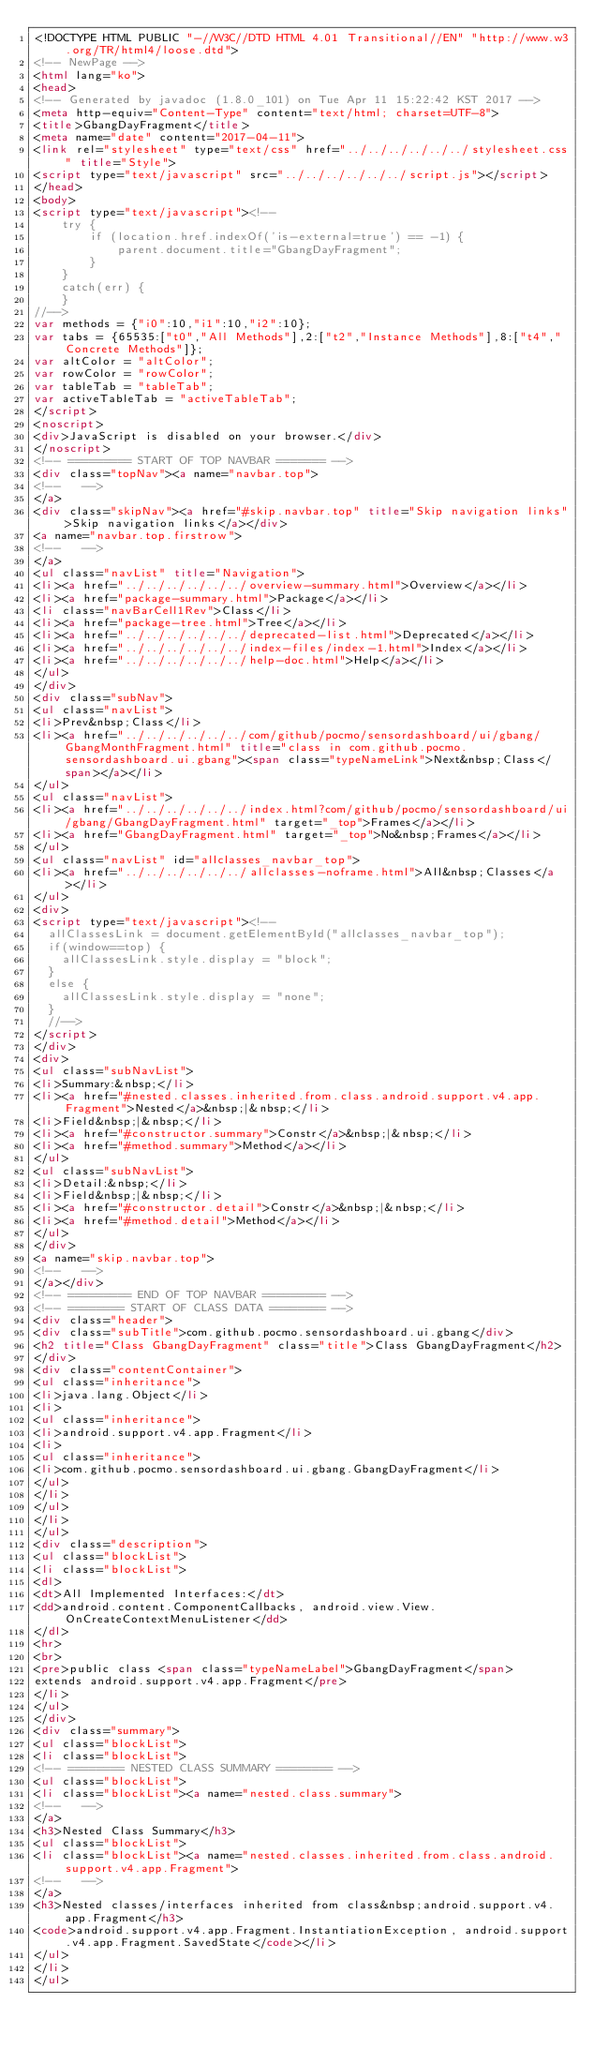<code> <loc_0><loc_0><loc_500><loc_500><_HTML_><!DOCTYPE HTML PUBLIC "-//W3C//DTD HTML 4.01 Transitional//EN" "http://www.w3.org/TR/html4/loose.dtd">
<!-- NewPage -->
<html lang="ko">
<head>
<!-- Generated by javadoc (1.8.0_101) on Tue Apr 11 15:22:42 KST 2017 -->
<meta http-equiv="Content-Type" content="text/html; charset=UTF-8">
<title>GbangDayFragment</title>
<meta name="date" content="2017-04-11">
<link rel="stylesheet" type="text/css" href="../../../../../../stylesheet.css" title="Style">
<script type="text/javascript" src="../../../../../../script.js"></script>
</head>
<body>
<script type="text/javascript"><!--
    try {
        if (location.href.indexOf('is-external=true') == -1) {
            parent.document.title="GbangDayFragment";
        }
    }
    catch(err) {
    }
//-->
var methods = {"i0":10,"i1":10,"i2":10};
var tabs = {65535:["t0","All Methods"],2:["t2","Instance Methods"],8:["t4","Concrete Methods"]};
var altColor = "altColor";
var rowColor = "rowColor";
var tableTab = "tableTab";
var activeTableTab = "activeTableTab";
</script>
<noscript>
<div>JavaScript is disabled on your browser.</div>
</noscript>
<!-- ========= START OF TOP NAVBAR ======= -->
<div class="topNav"><a name="navbar.top">
<!--   -->
</a>
<div class="skipNav"><a href="#skip.navbar.top" title="Skip navigation links">Skip navigation links</a></div>
<a name="navbar.top.firstrow">
<!--   -->
</a>
<ul class="navList" title="Navigation">
<li><a href="../../../../../../overview-summary.html">Overview</a></li>
<li><a href="package-summary.html">Package</a></li>
<li class="navBarCell1Rev">Class</li>
<li><a href="package-tree.html">Tree</a></li>
<li><a href="../../../../../../deprecated-list.html">Deprecated</a></li>
<li><a href="../../../../../../index-files/index-1.html">Index</a></li>
<li><a href="../../../../../../help-doc.html">Help</a></li>
</ul>
</div>
<div class="subNav">
<ul class="navList">
<li>Prev&nbsp;Class</li>
<li><a href="../../../../../../com/github/pocmo/sensordashboard/ui/gbang/GbangMonthFragment.html" title="class in com.github.pocmo.sensordashboard.ui.gbang"><span class="typeNameLink">Next&nbsp;Class</span></a></li>
</ul>
<ul class="navList">
<li><a href="../../../../../../index.html?com/github/pocmo/sensordashboard/ui/gbang/GbangDayFragment.html" target="_top">Frames</a></li>
<li><a href="GbangDayFragment.html" target="_top">No&nbsp;Frames</a></li>
</ul>
<ul class="navList" id="allclasses_navbar_top">
<li><a href="../../../../../../allclasses-noframe.html">All&nbsp;Classes</a></li>
</ul>
<div>
<script type="text/javascript"><!--
  allClassesLink = document.getElementById("allclasses_navbar_top");
  if(window==top) {
    allClassesLink.style.display = "block";
  }
  else {
    allClassesLink.style.display = "none";
  }
  //-->
</script>
</div>
<div>
<ul class="subNavList">
<li>Summary:&nbsp;</li>
<li><a href="#nested.classes.inherited.from.class.android.support.v4.app.Fragment">Nested</a>&nbsp;|&nbsp;</li>
<li>Field&nbsp;|&nbsp;</li>
<li><a href="#constructor.summary">Constr</a>&nbsp;|&nbsp;</li>
<li><a href="#method.summary">Method</a></li>
</ul>
<ul class="subNavList">
<li>Detail:&nbsp;</li>
<li>Field&nbsp;|&nbsp;</li>
<li><a href="#constructor.detail">Constr</a>&nbsp;|&nbsp;</li>
<li><a href="#method.detail">Method</a></li>
</ul>
</div>
<a name="skip.navbar.top">
<!--   -->
</a></div>
<!-- ========= END OF TOP NAVBAR ========= -->
<!-- ======== START OF CLASS DATA ======== -->
<div class="header">
<div class="subTitle">com.github.pocmo.sensordashboard.ui.gbang</div>
<h2 title="Class GbangDayFragment" class="title">Class GbangDayFragment</h2>
</div>
<div class="contentContainer">
<ul class="inheritance">
<li>java.lang.Object</li>
<li>
<ul class="inheritance">
<li>android.support.v4.app.Fragment</li>
<li>
<ul class="inheritance">
<li>com.github.pocmo.sensordashboard.ui.gbang.GbangDayFragment</li>
</ul>
</li>
</ul>
</li>
</ul>
<div class="description">
<ul class="blockList">
<li class="blockList">
<dl>
<dt>All Implemented Interfaces:</dt>
<dd>android.content.ComponentCallbacks, android.view.View.OnCreateContextMenuListener</dd>
</dl>
<hr>
<br>
<pre>public class <span class="typeNameLabel">GbangDayFragment</span>
extends android.support.v4.app.Fragment</pre>
</li>
</ul>
</div>
<div class="summary">
<ul class="blockList">
<li class="blockList">
<!-- ======== NESTED CLASS SUMMARY ======== -->
<ul class="blockList">
<li class="blockList"><a name="nested.class.summary">
<!--   -->
</a>
<h3>Nested Class Summary</h3>
<ul class="blockList">
<li class="blockList"><a name="nested.classes.inherited.from.class.android.support.v4.app.Fragment">
<!--   -->
</a>
<h3>Nested classes/interfaces inherited from class&nbsp;android.support.v4.app.Fragment</h3>
<code>android.support.v4.app.Fragment.InstantiationException, android.support.v4.app.Fragment.SavedState</code></li>
</ul>
</li>
</ul></code> 